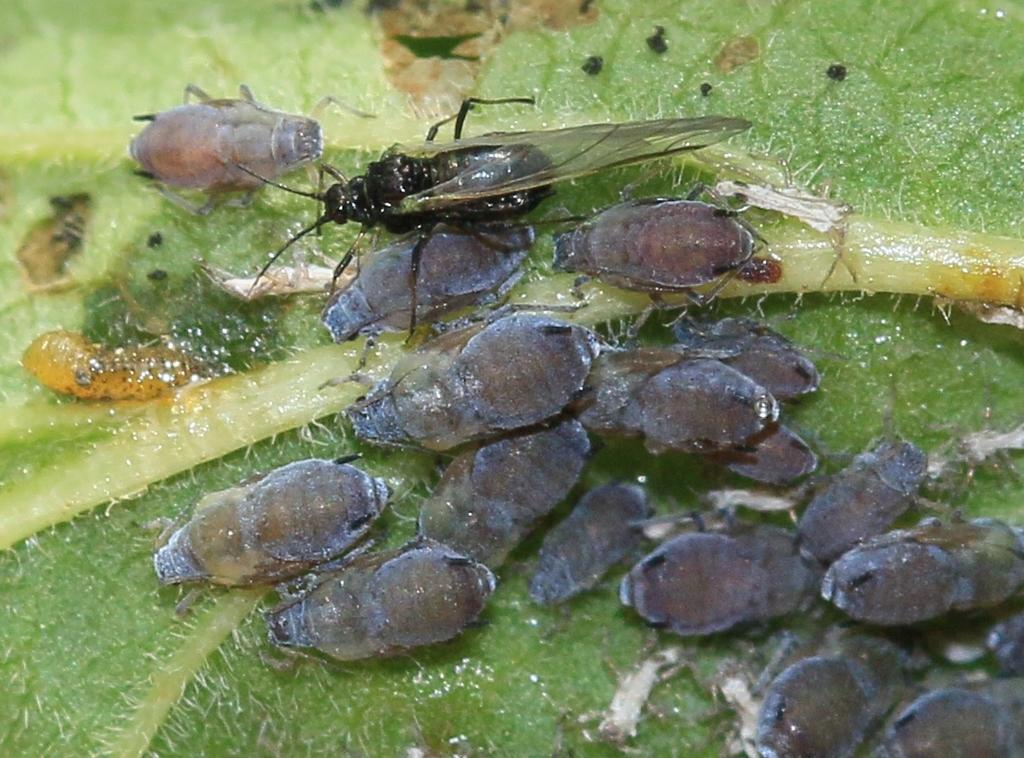Please provide a concise description of this image. In this image there are some insects on the leaf as we can see in the middle of this image. 